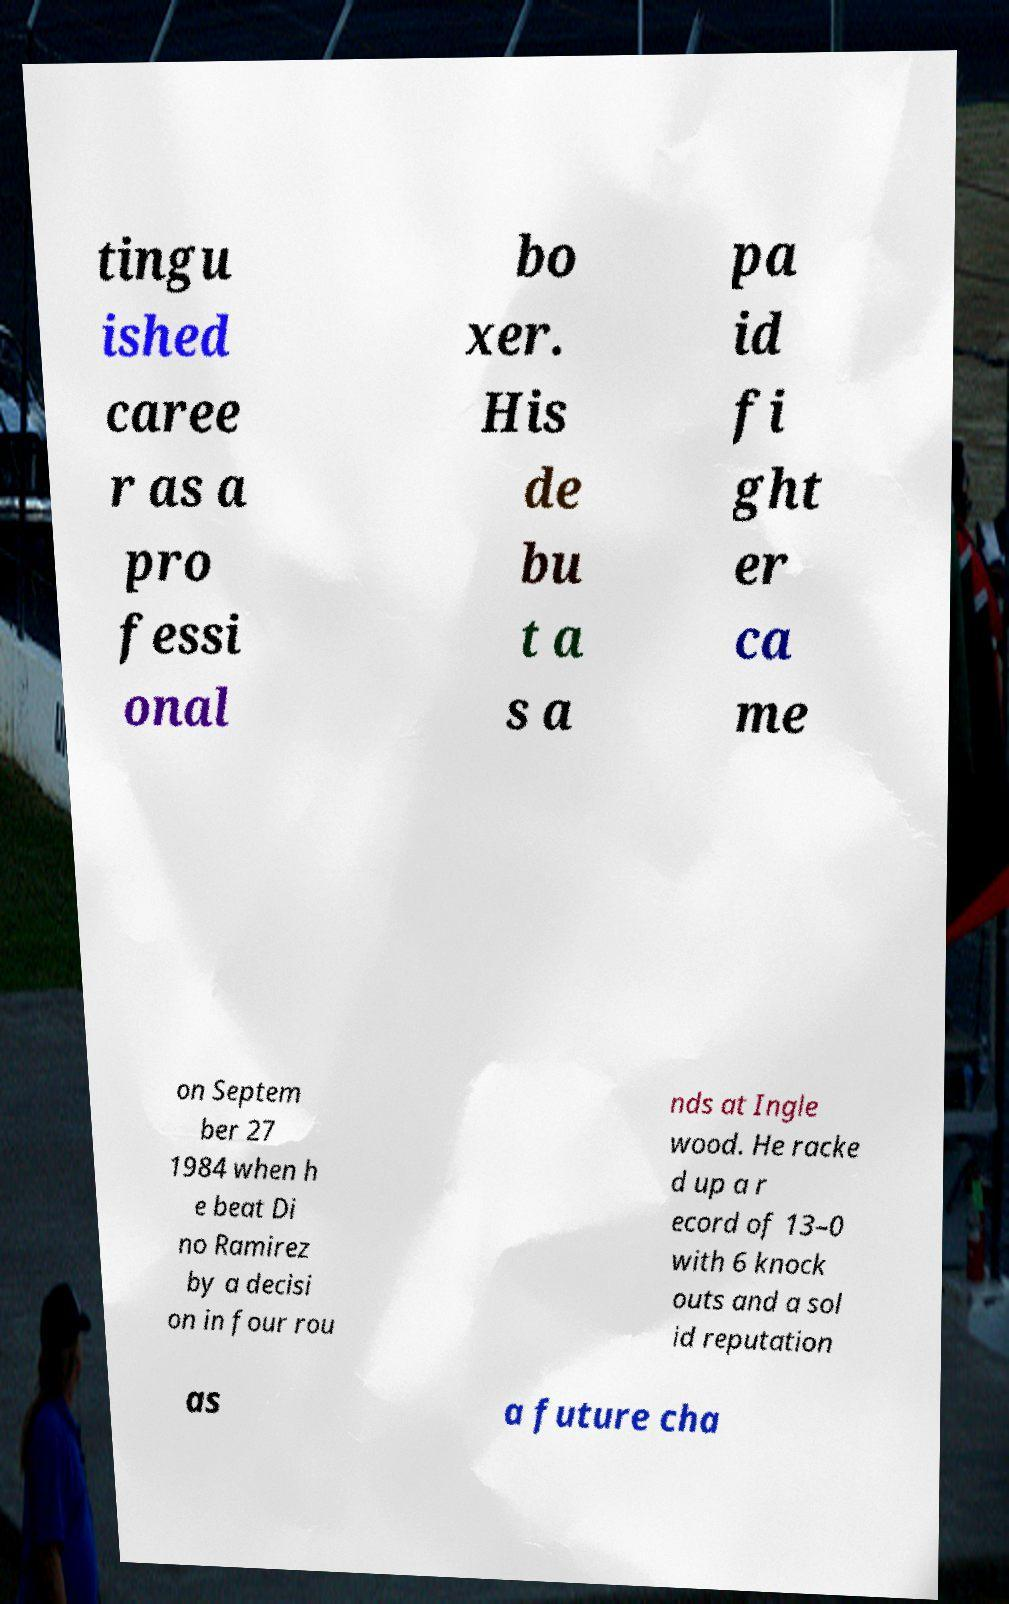I need the written content from this picture converted into text. Can you do that? tingu ished caree r as a pro fessi onal bo xer. His de bu t a s a pa id fi ght er ca me on Septem ber 27 1984 when h e beat Di no Ramirez by a decisi on in four rou nds at Ingle wood. He racke d up a r ecord of 13–0 with 6 knock outs and a sol id reputation as a future cha 